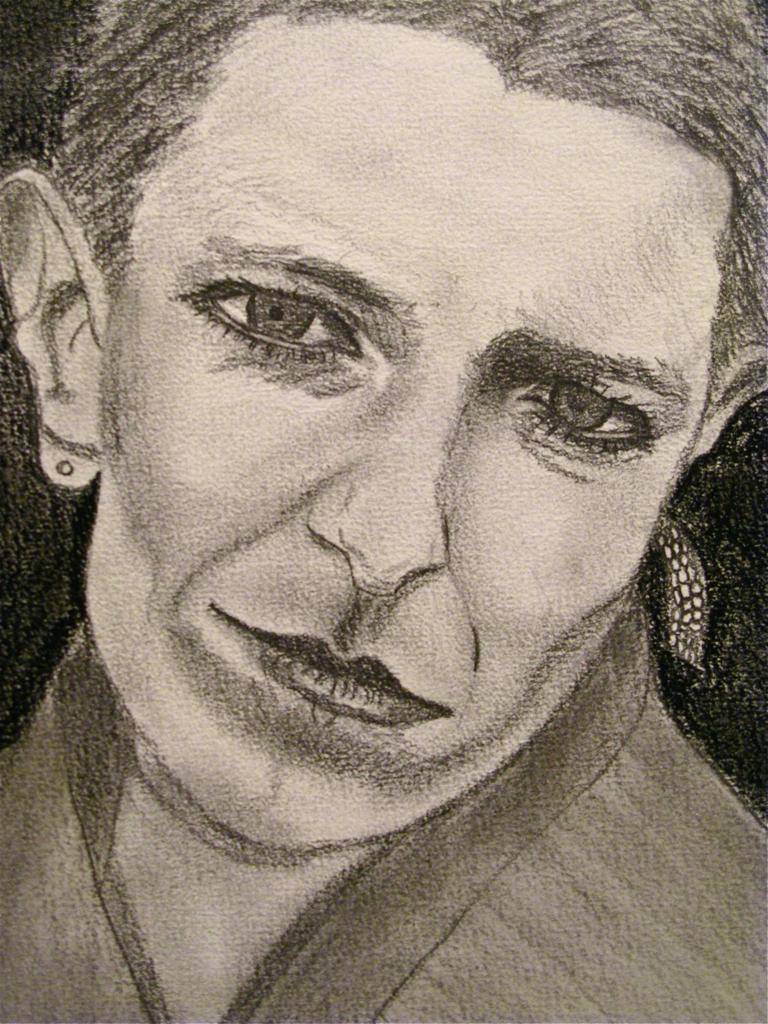What is the main subject of the image? There is a painting in the image. What is depicted in the painting? The painting contains a woman. What type of mint can be seen growing along the coast in the image? There is no mention of mint or a coast in the image; it only contains a painting with a woman. 